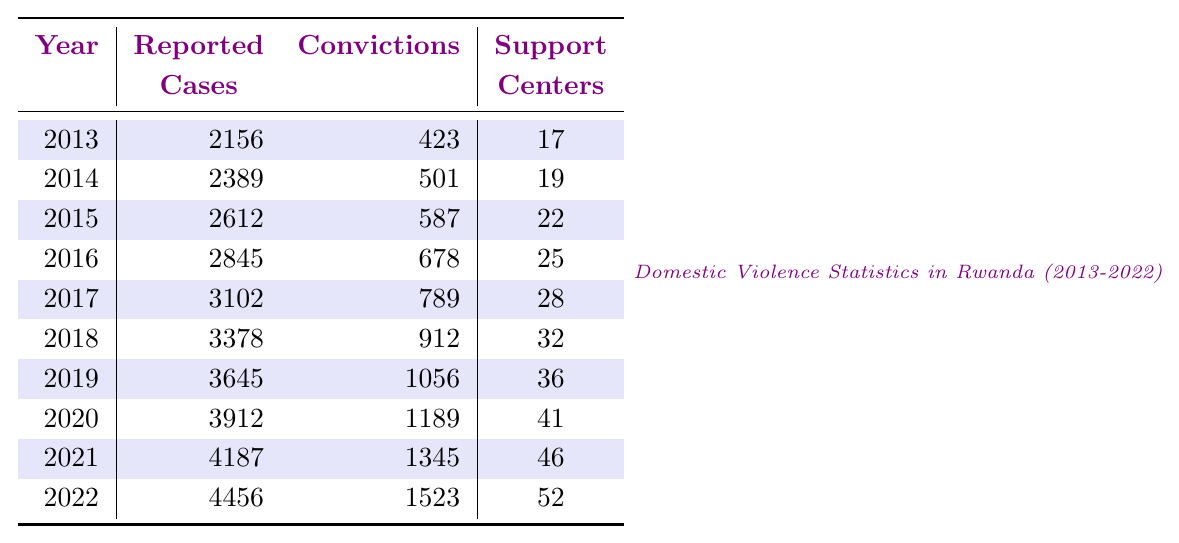What is the number of reported cases of domestic violence in 2019? Looking at the table for the year 2019, the number of reported cases is directly listed under the "Reported Cases" column as 3645.
Answer: 3645 How many convictions were made in 2021? The table shows that in 2021, the number of convictions is listed under the "Convictions" column as 1345.
Answer: 1345 In which year were the fewest support centers reported? By examining the "Support Centers" column, we can see that the year with the fewest centers is 2013, which had 17 support centers.
Answer: 2013 What is the total number of reported domestic violence cases from 2013 to 2022? To find the total, we sum the reported cases from each year: 2156 + 2389 + 2612 + 2845 + 3102 + 3378 + 3645 + 3912 + 4187 + 4456 = 27242.
Answer: 27242 What percentage of reported cases in 2020 resulted in convictions? For 2020, we can find the percentage by dividing the number of convictions (1189) by the number of reported cases (3912) and then multiplying by 100. So, (1189/3912) * 100 ≈ 30.4%.
Answer: Approximately 30.4% How many more convictions were made in 2022 compared to 2014? We find the number of convictions for 2022 (1523) and for 2014 (501), then subtract: 1523 - 501 = 1022.
Answer: 1022 What was the average number of reported cases per year from 2013 to 2022? There are 10 years in total, with a total of 27242 reported cases. To find the average, we divide the total by the number of years: 27242 / 10 = 2724.2.
Answer: 2724.2 Did the number of reported domestic violence cases increase every year from 2013 to 2022? By looking at the reported cases for each year, we see that they consistently increase: 2156, 2389, 2612, 2845, 3102, 3378, 3645, 3912, 4187, 4456, indicating a continuous increase.
Answer: Yes What is the ratio of reported cases to convictions in 2016? For 2016, the reported cases were 2845 and the convictions were 678. We calculate the ratio by dividing: 2845 / 678 ≈ 4.20.
Answer: Approximately 4.20 What trend can be observed in the number of support centers from 2013 to 2022? By looking at the "Support Centers" column, we see an upward trend from 17 in 2013 to 52 in 2022, indicating an increase over the years.
Answer: Increasing trend 